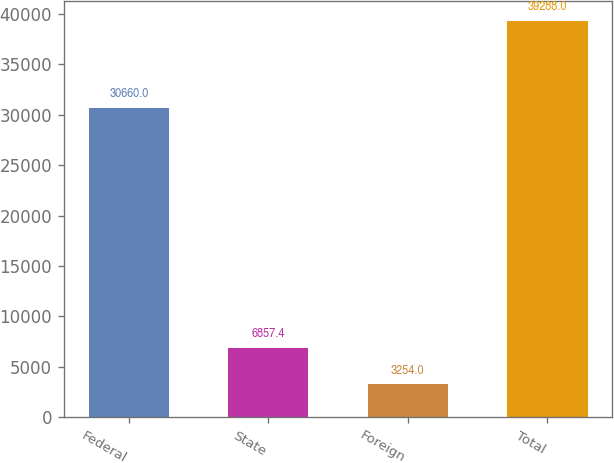Convert chart. <chart><loc_0><loc_0><loc_500><loc_500><bar_chart><fcel>Federal<fcel>State<fcel>Foreign<fcel>Total<nl><fcel>30660<fcel>6857.4<fcel>3254<fcel>39288<nl></chart> 